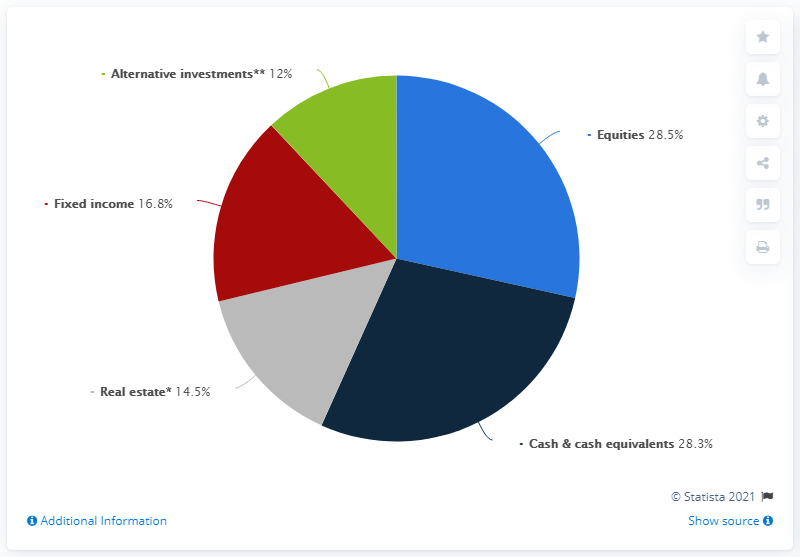Point out several critical features in this image. The addition of equities and real estate would result in a percentage that is 43. In 2018, a significant portion of the assets owned by High Net Worth Individuals (HNWI's) in Europe were invested in equities, with 28.5% of their assets held in this type of investment. The blue color in the pie chart denotes equities. A recent study on high net worth individuals (HNWI's) in Europe found that a significant portion, approximately 28.5%, of their assets were held in cash and cash equivalents. 